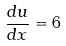Convert formula to latex. <formula><loc_0><loc_0><loc_500><loc_500>\frac { d u } { d x } = 6</formula> 